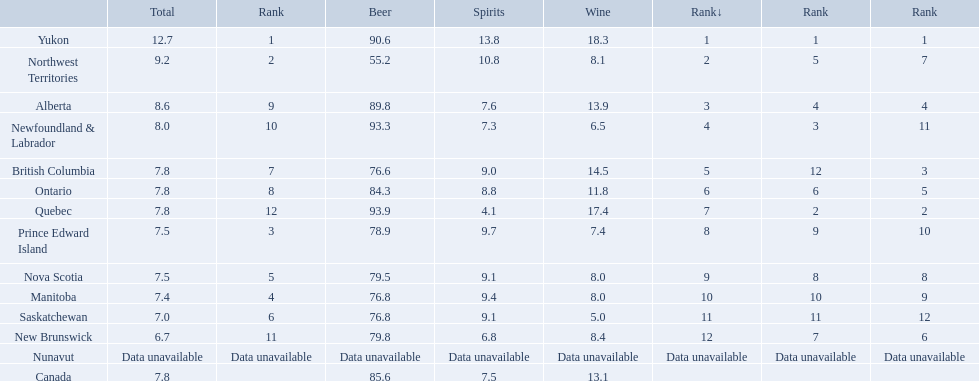What is the first ranked alcoholic beverage in canada Yukon. How many litters is consumed a year? 12.7. Which locations consume the same total amount of alcoholic beverages as another location? British Columbia, Ontario, Quebec, Prince Edward Island, Nova Scotia. Which of these consumes more then 80 of beer? Ontario, Quebec. Of those what was the consumption of spirits of the one that consumed the most beer? 4.1. 